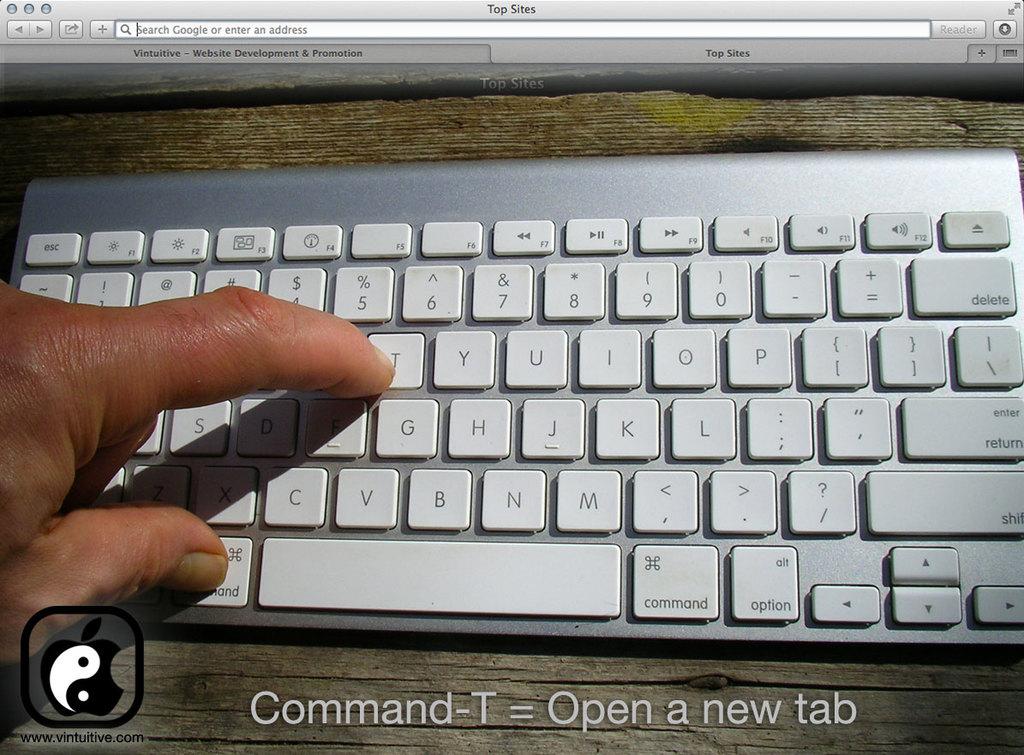What key is his finger on?
Your answer should be compact. T. What key is his thumb on?
Offer a very short reply. Command. 